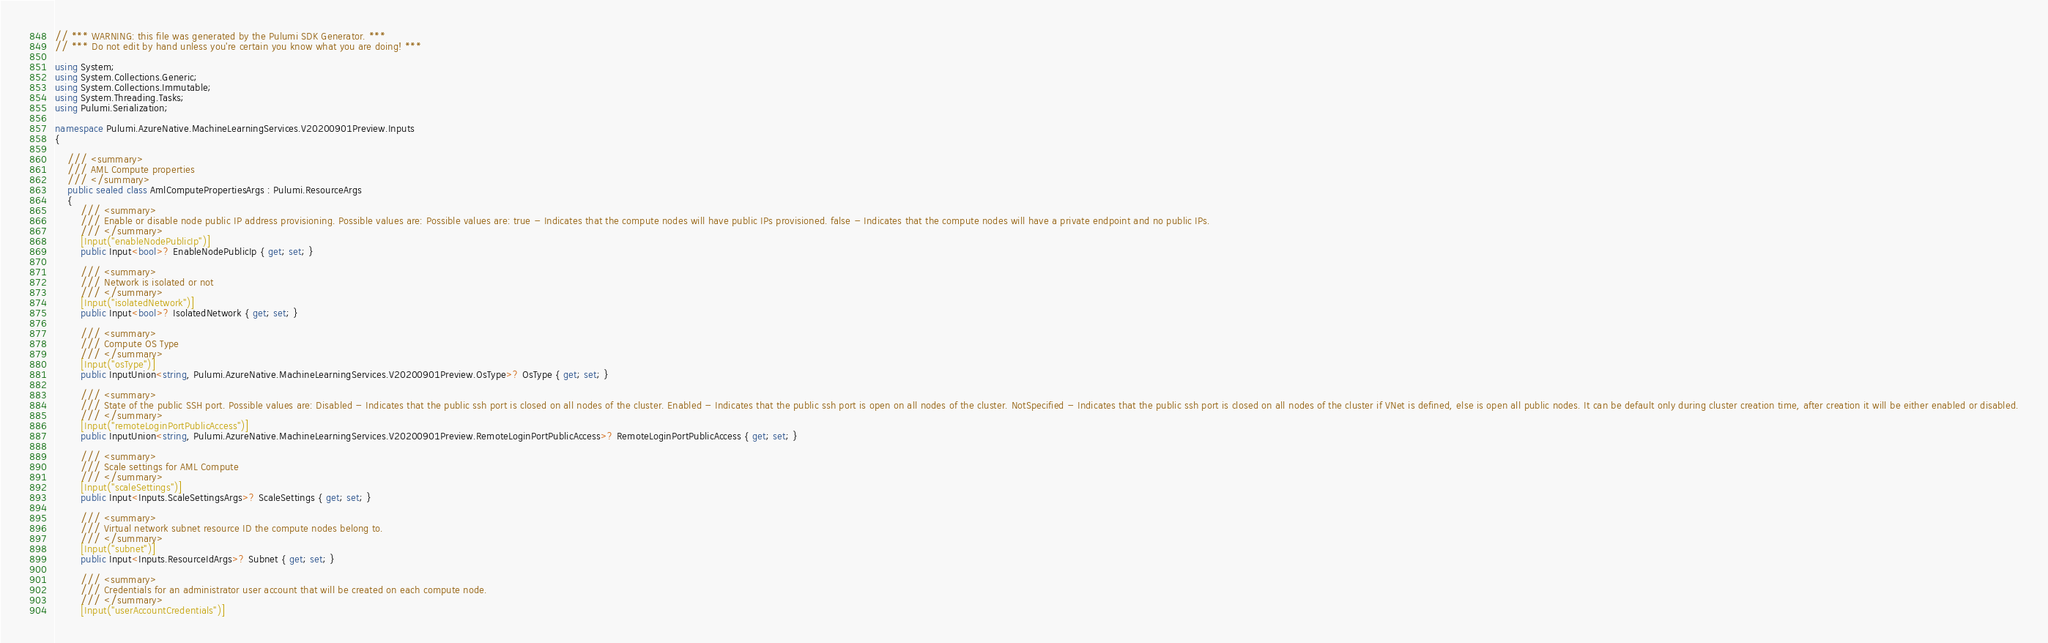<code> <loc_0><loc_0><loc_500><loc_500><_C#_>// *** WARNING: this file was generated by the Pulumi SDK Generator. ***
// *** Do not edit by hand unless you're certain you know what you are doing! ***

using System;
using System.Collections.Generic;
using System.Collections.Immutable;
using System.Threading.Tasks;
using Pulumi.Serialization;

namespace Pulumi.AzureNative.MachineLearningServices.V20200901Preview.Inputs
{

    /// <summary>
    /// AML Compute properties
    /// </summary>
    public sealed class AmlComputePropertiesArgs : Pulumi.ResourceArgs
    {
        /// <summary>
        /// Enable or disable node public IP address provisioning. Possible values are: Possible values are: true - Indicates that the compute nodes will have public IPs provisioned. false - Indicates that the compute nodes will have a private endpoint and no public IPs.
        /// </summary>
        [Input("enableNodePublicIp")]
        public Input<bool>? EnableNodePublicIp { get; set; }

        /// <summary>
        /// Network is isolated or not
        /// </summary>
        [Input("isolatedNetwork")]
        public Input<bool>? IsolatedNetwork { get; set; }

        /// <summary>
        /// Compute OS Type
        /// </summary>
        [Input("osType")]
        public InputUnion<string, Pulumi.AzureNative.MachineLearningServices.V20200901Preview.OsType>? OsType { get; set; }

        /// <summary>
        /// State of the public SSH port. Possible values are: Disabled - Indicates that the public ssh port is closed on all nodes of the cluster. Enabled - Indicates that the public ssh port is open on all nodes of the cluster. NotSpecified - Indicates that the public ssh port is closed on all nodes of the cluster if VNet is defined, else is open all public nodes. It can be default only during cluster creation time, after creation it will be either enabled or disabled.
        /// </summary>
        [Input("remoteLoginPortPublicAccess")]
        public InputUnion<string, Pulumi.AzureNative.MachineLearningServices.V20200901Preview.RemoteLoginPortPublicAccess>? RemoteLoginPortPublicAccess { get; set; }

        /// <summary>
        /// Scale settings for AML Compute
        /// </summary>
        [Input("scaleSettings")]
        public Input<Inputs.ScaleSettingsArgs>? ScaleSettings { get; set; }

        /// <summary>
        /// Virtual network subnet resource ID the compute nodes belong to.
        /// </summary>
        [Input("subnet")]
        public Input<Inputs.ResourceIdArgs>? Subnet { get; set; }

        /// <summary>
        /// Credentials for an administrator user account that will be created on each compute node.
        /// </summary>
        [Input("userAccountCredentials")]</code> 